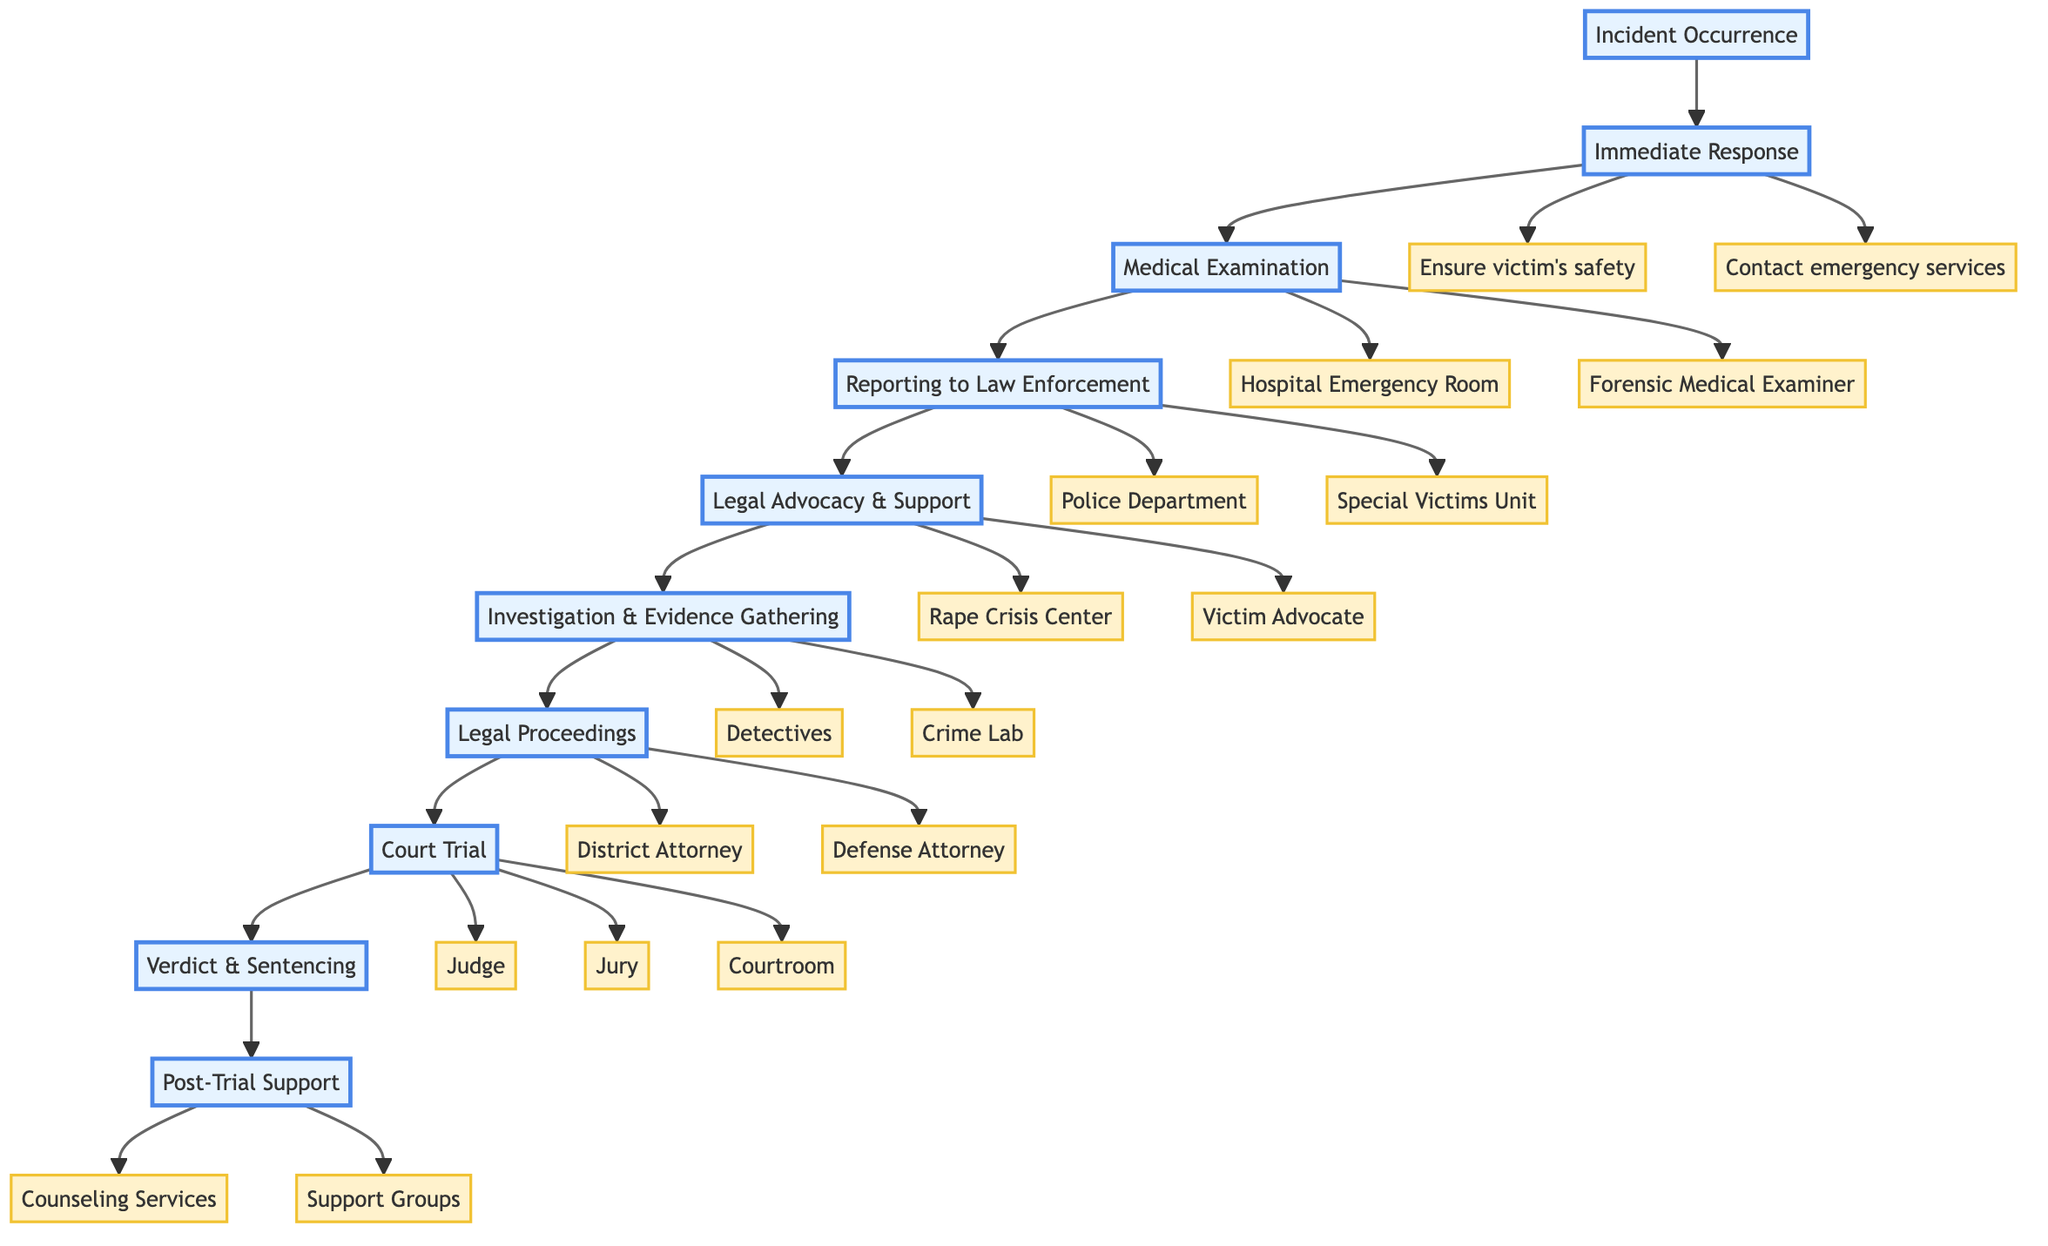What stage follows Medical Examination? The flowchart indicates that after Medical Examination, the next stage is Reporting to Law Enforcement. This is identified by tracing the path from C (Medical Examination) to D (Reporting to Law Enforcement).
Answer: Reporting to Law Enforcement How many total stages are present in the support process? By counting the number of distinct stages in the flowchart, we see there are ten stages ranging from Incident Occurrence to Post-Trial Support. Each stage is separated by arrows indicating the flow of the process.
Answer: 10 What action is taken in Immediate Response? Immediate Response consists of two actions: ensuring the victim's safety and contacting emergency services. These actions are directly listed under the Immediate Response stage in the diagram.
Answer: Ensure victim's safety, Contact emergency services Which entities are involved in the Legal Proceedings stage? The entities listed under the Legal Proceedings stage are the District Attorney and Defense Attorney. These are highlighted in the flowchart as part of that specific stage.
Answer: District Attorney, Defense Attorney What comes before Court Trial in the flowchart? The stage that comes directly before Court Trial is Legal Proceedings. This can be seen by following the arrow flow from G (Legal Proceedings) to H (Court Trial).
Answer: Legal Proceedings Which actions are part of Post-Trial Support? The actions associated with Post-Trial Support include providing ongoing emotional support and assisting with victim compensation claims. These actions appear directly beneath the Post-Trial Support stage in the diagram.
Answer: Provide ongoing emotional support, Assist with victim compensation claims How many entities are indicated in the Medical Examination stage? There are two entities listed under the Medical Examination stage, which are the Hospital Emergency Room and the Forensic Medical Examiner. This is identified by examining the Medical Examination section of the flowchart.
Answer: 2 Which stage is linked directly to Investigation & Evidence Gathering? The stage linked directly to Investigation & Evidence Gathering is Legal Advocacy & Support, as indicated by the flowchart's arrow connecting E (Legal Advocacy & Support) to F (Investigation & Evidence Gathering).
Answer: Legal Advocacy & Support What is the final stage in the flowchart? The final stage listed in the flowchart is Post-Trial Support. This can be determined by identifying the last node in the flow of the diagram.
Answer: Post-Trial Support 